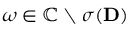Convert formula to latex. <formula><loc_0><loc_0><loc_500><loc_500>\omega \in \mathbb { C } \ \sigma ( { D } )</formula> 